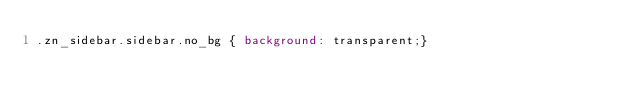Convert code to text. <code><loc_0><loc_0><loc_500><loc_500><_CSS_>.zn_sidebar.sidebar.no_bg { background: transparent;}</code> 